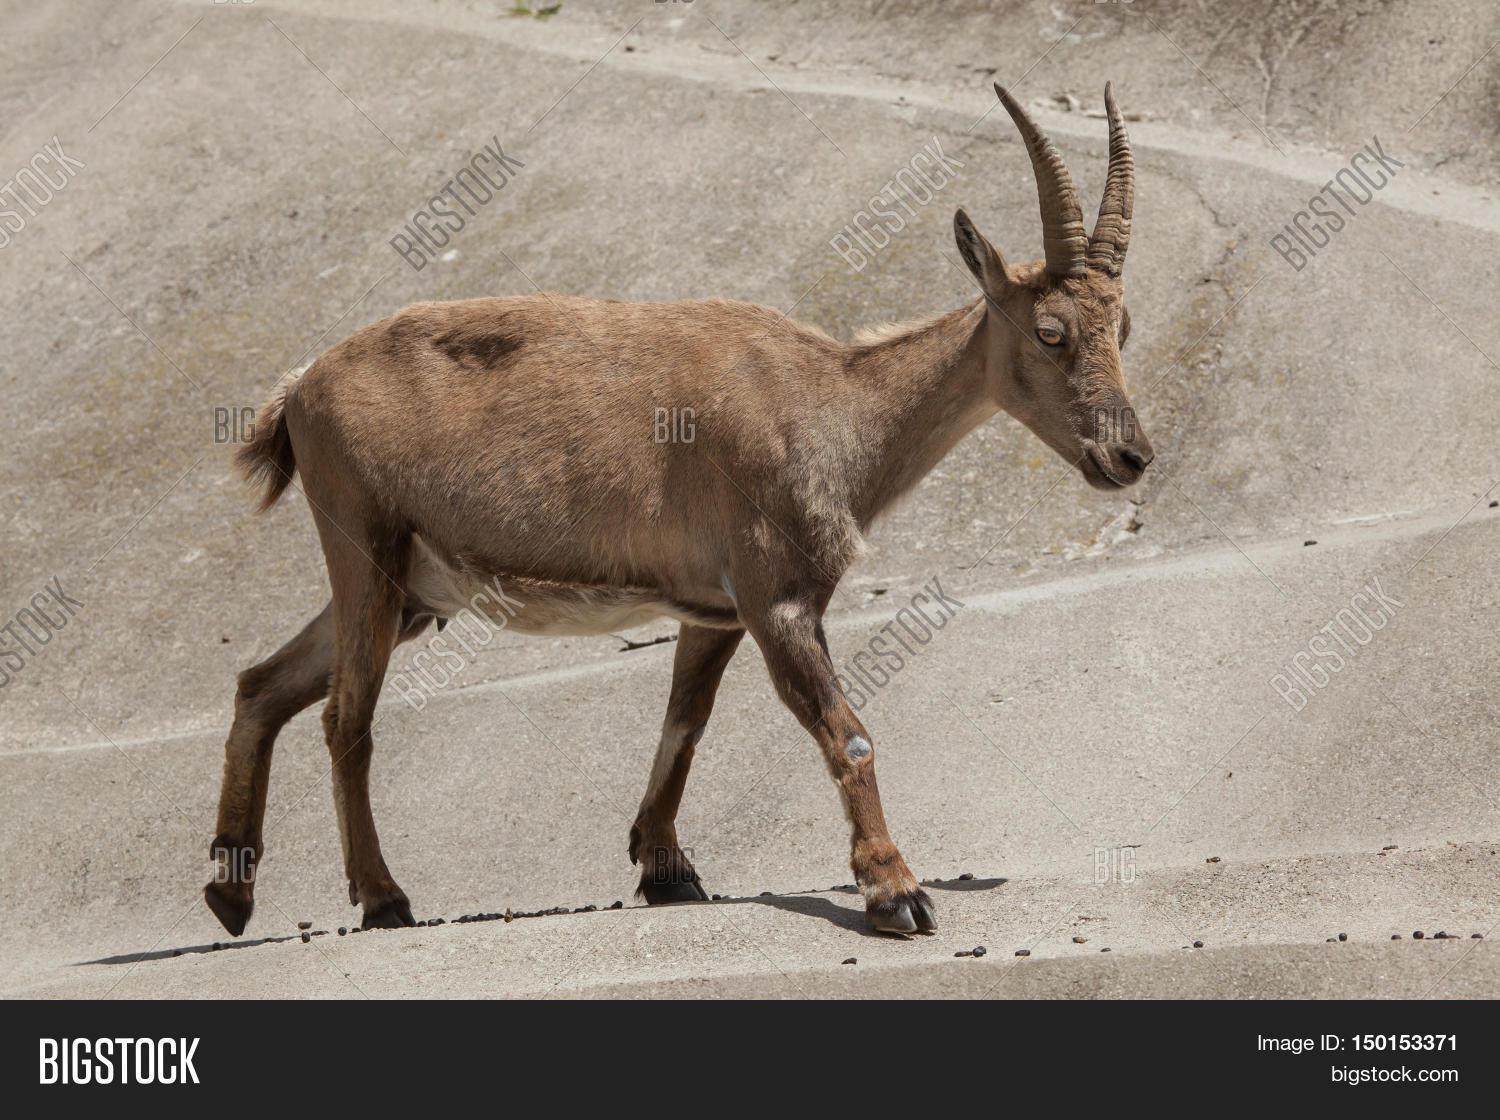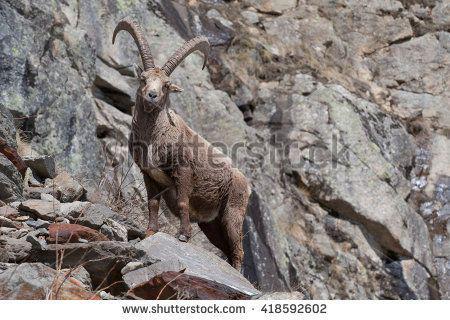The first image is the image on the left, the second image is the image on the right. Assess this claim about the two images: "There are exactly two mountain goats.". Correct or not? Answer yes or no. Yes. The first image is the image on the left, the second image is the image on the right. For the images displayed, is the sentence "There are only two goats visible." factually correct? Answer yes or no. Yes. 